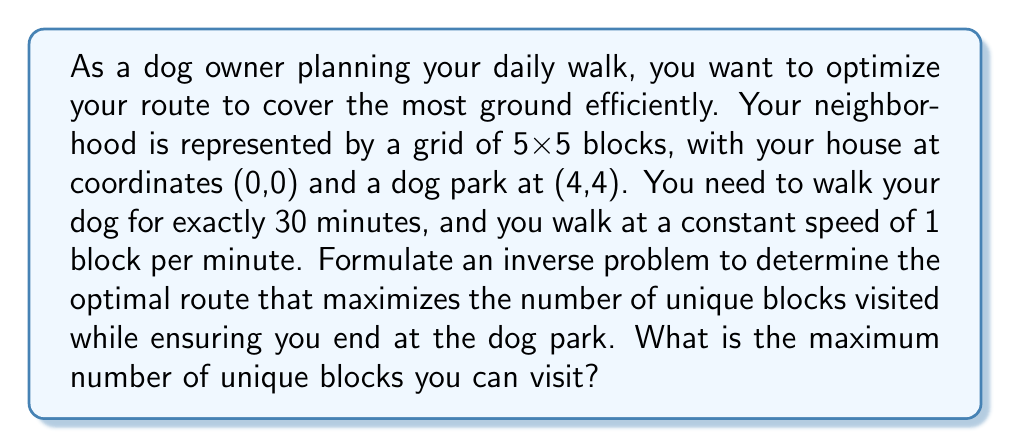Teach me how to tackle this problem. Let's approach this step-by-step:

1) First, we need to understand the constraints:
   - The grid is 5x5, so there are 25 possible blocks to visit.
   - Start point: (0,0)
   - End point: (4,4)
   - Total time: 30 minutes
   - Speed: 1 block per minute

2) The inverse problem here is to find the path that maximizes unique blocks visited given these constraints.

3) To reach (4,4) from (0,0), we need to move 4 blocks right and 4 blocks up, which requires at least 8 minutes.

4) We have 30 minutes total, so we can make 30 moves in total.

5) The optimal strategy is to zigzag through the grid to cover as many unique blocks as possible.

6) Let's visualize the optimal path:

   [asy]
   unitsize(1cm);
   for(int i=0; i<=5; ++i) {
     draw((0,i)--(5,i),gray);
     draw((i,0)--(i,5),gray);
   }
   draw((0,0)--(1,0)--(1,1)--(2,1)--(2,2)--(3,2)--(3,3)--(4,3)--(4,4),red+1);
   draw((0,0)--(0,1)--(1,1)--(1,2)--(2,2)--(2,3)--(3,3)--(3,4)--(4,4),blue+1);
   label("Start",(0,0),SW);
   label("End",(4,4),NE);
   [/asy]

7) The red path shows the first 8 moves, and the blue path shows the return 8 moves.

8) We can see that this path covers 9 unique blocks (including start and end).

9) We still have 14 moves left (30 - 16 = 14).

10) We can use these 14 moves to visit 7 more unique blocks by making small detours from our main path.

11) Therefore, the maximum number of unique blocks we can visit is 9 + 7 = 16.
Answer: 16 blocks 